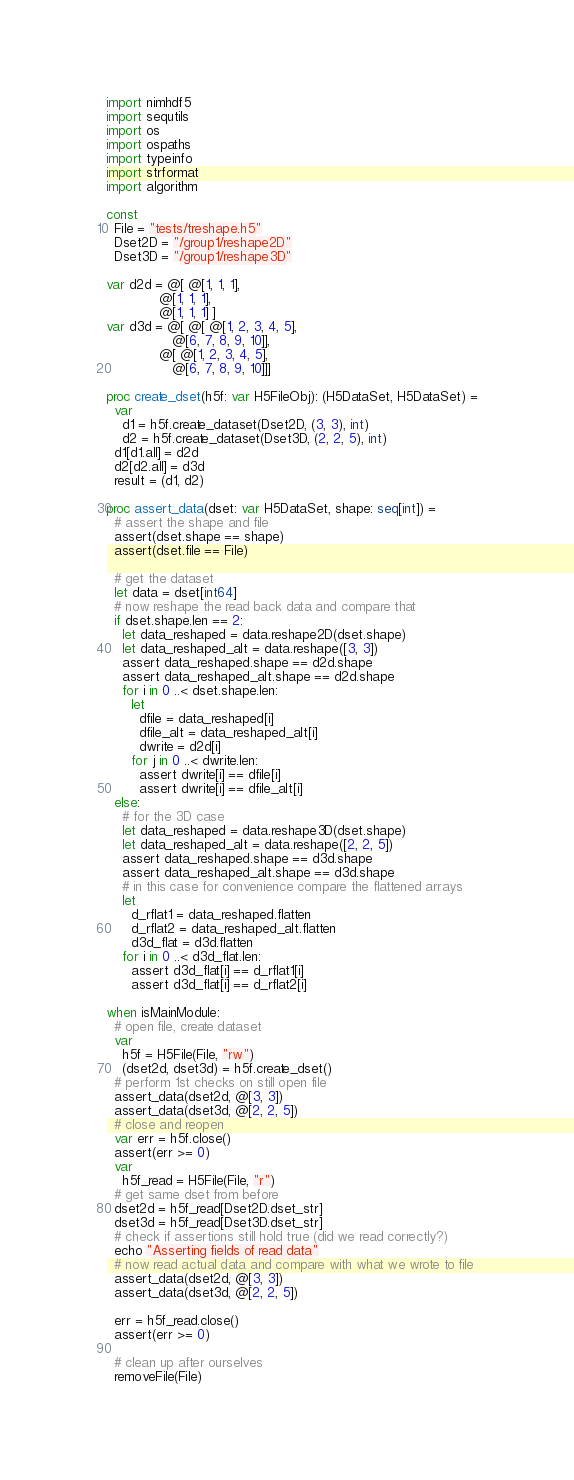<code> <loc_0><loc_0><loc_500><loc_500><_Nim_>import nimhdf5
import sequtils
import os
import ospaths
import typeinfo
import strformat
import algorithm

const
  File = "tests/treshape.h5"
  Dset2D = "/group1/reshape2D"
  Dset3D = "/group1/reshape3D"

var d2d = @[ @[1, 1, 1],
             @[1, 1, 1],
             @[1, 1, 1] ]
var d3d = @[ @[ @[1, 2, 3, 4, 5],
                @[6, 7, 8, 9, 10]],
             @[ @[1, 2, 3, 4, 5],
                @[6, 7, 8, 9, 10]]]

proc create_dset(h5f: var H5FileObj): (H5DataSet, H5DataSet) =
  var
    d1 = h5f.create_dataset(Dset2D, (3, 3), int)
    d2 = h5f.create_dataset(Dset3D, (2, 2, 5), int)
  d1[d1.all] = d2d
  d2[d2.all] = d3d
  result = (d1, d2)

proc assert_data(dset: var H5DataSet, shape: seq[int]) =
  # assert the shape and file
  assert(dset.shape == shape)
  assert(dset.file == File)

  # get the dataset
  let data = dset[int64]
  # now reshape the read back data and compare that
  if dset.shape.len == 2:
    let data_reshaped = data.reshape2D(dset.shape)
    let data_reshaped_alt = data.reshape([3, 3])
    assert data_reshaped.shape == d2d.shape
    assert data_reshaped_alt.shape == d2d.shape
    for i in 0 ..< dset.shape.len:
      let
        dfile = data_reshaped[i]
        dfile_alt = data_reshaped_alt[i]
        dwrite = d2d[i]
      for j in 0 ..< dwrite.len:
        assert dwrite[i] == dfile[i]
        assert dwrite[i] == dfile_alt[i]
  else:
    # for the 3D case
    let data_reshaped = data.reshape3D(dset.shape)
    let data_reshaped_alt = data.reshape([2, 2, 5])
    assert data_reshaped.shape == d3d.shape
    assert data_reshaped_alt.shape == d3d.shape
    # in this case for convenience compare the flattened arrays
    let
      d_rflat1 = data_reshaped.flatten
      d_rflat2 = data_reshaped_alt.flatten
      d3d_flat = d3d.flatten
    for i in 0 ..< d3d_flat.len:
      assert d3d_flat[i] == d_rflat1[i]
      assert d3d_flat[i] == d_rflat2[i]

when isMainModule:
  # open file, create dataset
  var
    h5f = H5File(File, "rw")
    (dset2d, dset3d) = h5f.create_dset()
  # perform 1st checks on still open file
  assert_data(dset2d, @[3, 3])
  assert_data(dset3d, @[2, 2, 5])
  # close and reopen
  var err = h5f.close()
  assert(err >= 0)
  var
    h5f_read = H5File(File, "r")
  # get same dset from before
  dset2d = h5f_read[Dset2D.dset_str]
  dset3d = h5f_read[Dset3D.dset_str]
  # check if assertions still hold true (did we read correctly?)
  echo "Asserting fields of read data"
  # now read actual data and compare with what we wrote to file
  assert_data(dset2d, @[3, 3])
  assert_data(dset3d, @[2, 2, 5])

  err = h5f_read.close()
  assert(err >= 0)

  # clean up after ourselves
  removeFile(File)
</code> 